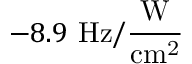<formula> <loc_0><loc_0><loc_500><loc_500>- 8 . 9 H z / \frac { W } { c m ^ { 2 } }</formula> 